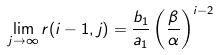<formula> <loc_0><loc_0><loc_500><loc_500>\lim _ { j \rightarrow \infty } r ( i - 1 , j ) = \frac { b _ { 1 } } { a _ { 1 } } \left ( \frac { \beta } { \alpha } \right ) ^ { i - 2 }</formula> 